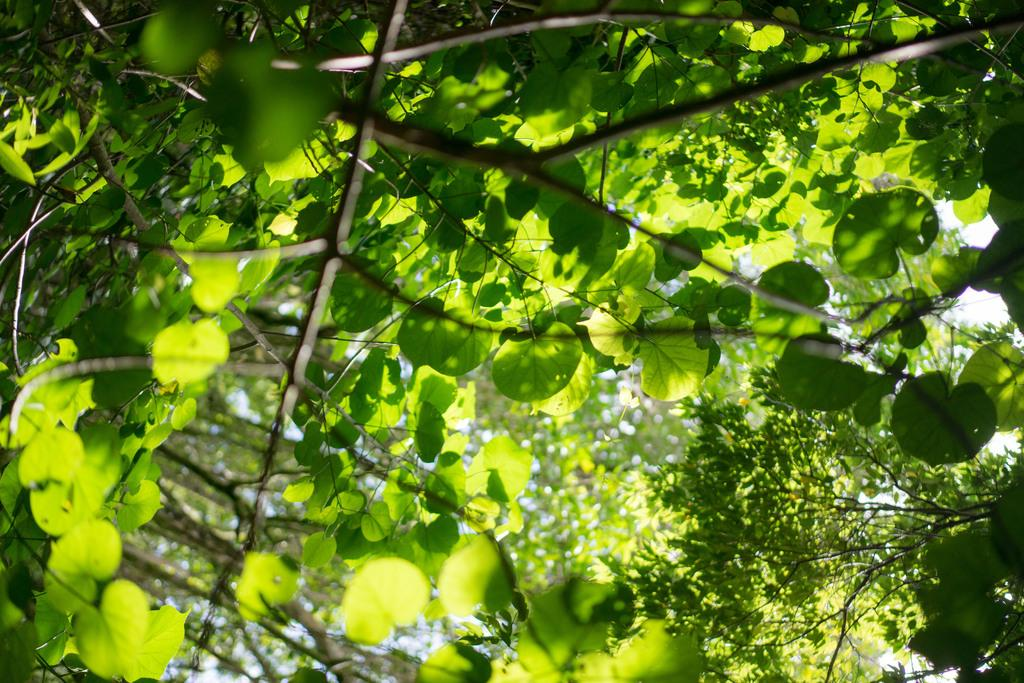What type of vegetation can be seen in the picture? There are trees in the picture. What is the color of the leaves on the trees? The trees have green leaves. Where is the library located in the picture? There is no library present in the picture; it only features trees with green leaves. How many rings can be seen on the trees in the picture? There is no information about rings on the trees in the provided facts, so it cannot be determined from the image. 